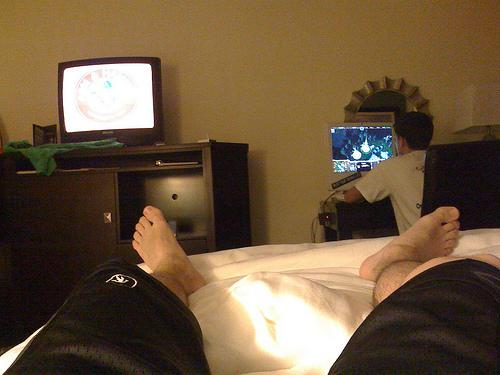Question: who is at the computer?
Choices:
A. A woman in a blue dress.
B. A girl in shorts.
C. A man in a yellow tank top.
D. A boy in white shirt.
Answer with the letter. Answer: D Question: how many people are there?
Choices:
A. Two.
B. Three.
C. Four.
D. Six.
Answer with the letter. Answer: A Question: what is the person on the bed doing?
Choices:
A. Sleeping.
B. Dreaming.
C. Sitting.
D. Laying down.
Answer with the letter. Answer: D Question: where is the boy sitting?
Choices:
A. In a chair.
B. On the sofa.
C. At the movies.
D. At a desk.
Answer with the letter. Answer: D 